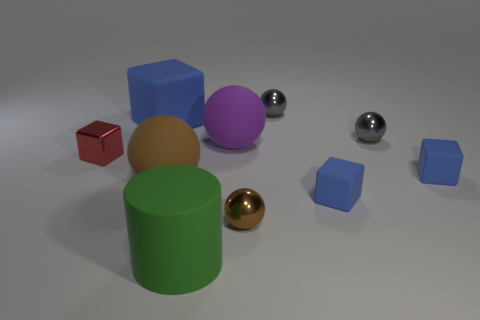Subtract all blue cylinders. How many blue cubes are left? 3 Subtract all big blue blocks. How many blocks are left? 3 Subtract 3 balls. How many balls are left? 2 Subtract all purple spheres. How many spheres are left? 4 Subtract all gray blocks. Subtract all brown spheres. How many blocks are left? 4 Subtract all cubes. How many objects are left? 6 Add 6 big purple matte spheres. How many big purple matte spheres exist? 7 Subtract 0 green balls. How many objects are left? 10 Subtract all cyan metallic things. Subtract all red metallic cubes. How many objects are left? 9 Add 3 green rubber cylinders. How many green rubber cylinders are left? 4 